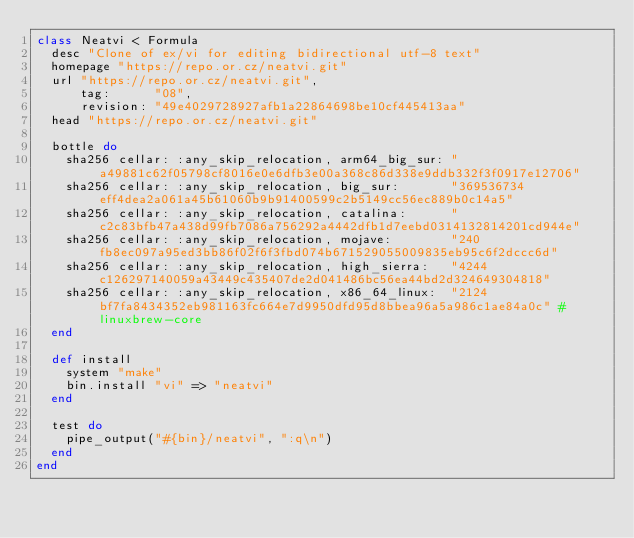Convert code to text. <code><loc_0><loc_0><loc_500><loc_500><_Ruby_>class Neatvi < Formula
  desc "Clone of ex/vi for editing bidirectional utf-8 text"
  homepage "https://repo.or.cz/neatvi.git"
  url "https://repo.or.cz/neatvi.git",
      tag:      "08",
      revision: "49e4029728927afb1a22864698be10cf445413aa"
  head "https://repo.or.cz/neatvi.git"

  bottle do
    sha256 cellar: :any_skip_relocation, arm64_big_sur: "a49881c62f05798cf8016e0e6dfb3e00a368c86d338e9ddb332f3f0917e12706"
    sha256 cellar: :any_skip_relocation, big_sur:       "369536734eff4dea2a061a45b61060b9b91400599c2b5149cc56ec889b0c14a5"
    sha256 cellar: :any_skip_relocation, catalina:      "c2c83bfb47a438d99fb7086a756292a4442dfb1d7eebd0314132814201cd944e"
    sha256 cellar: :any_skip_relocation, mojave:        "240fb8ec097a95ed3bb86f02f6f3fbd074b671529055009835eb95c6f2dccc6d"
    sha256 cellar: :any_skip_relocation, high_sierra:   "4244c126297140059a43449c435407de2d041486bc56ea44bd2d324649304818"
    sha256 cellar: :any_skip_relocation, x86_64_linux:  "2124bf7fa8434352eb981163fc664e7d9950dfd95d8bbea96a5a986c1ae84a0c" # linuxbrew-core
  end

  def install
    system "make"
    bin.install "vi" => "neatvi"
  end

  test do
    pipe_output("#{bin}/neatvi", ":q\n")
  end
end
</code> 